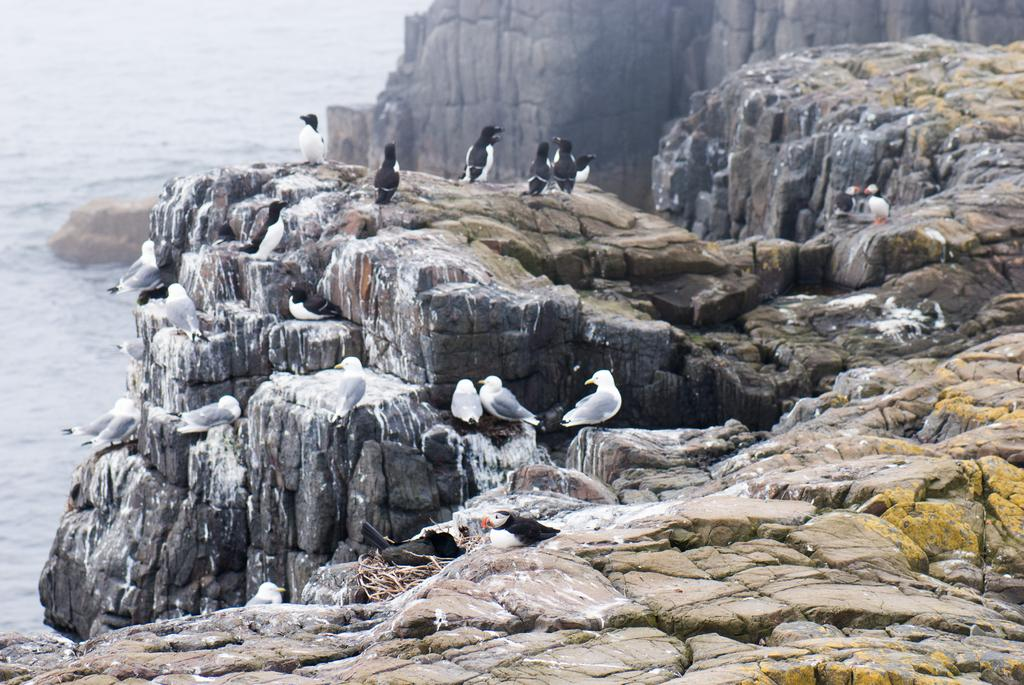What type of landscape can be seen in the image? There are hills in the image. What can be found on the hills? Beautiful birds are present on the hills. What is located in front of the hills? There is a sea in front of the hills. What is the price of the snake in the image? There is no snake present in the image, so it is not possible to determine its price. 